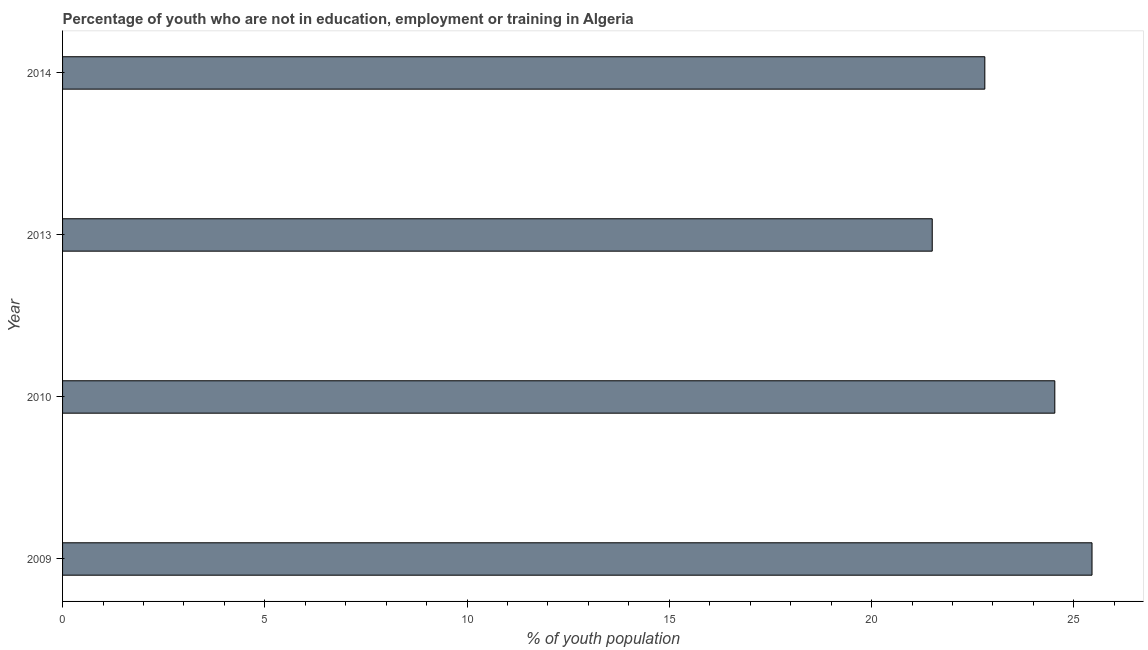Does the graph contain grids?
Make the answer very short. No. What is the title of the graph?
Make the answer very short. Percentage of youth who are not in education, employment or training in Algeria. What is the label or title of the X-axis?
Offer a very short reply. % of youth population. What is the label or title of the Y-axis?
Your answer should be compact. Year. What is the unemployed youth population in 2013?
Your answer should be very brief. 21.5. Across all years, what is the maximum unemployed youth population?
Ensure brevity in your answer.  25.45. Across all years, what is the minimum unemployed youth population?
Ensure brevity in your answer.  21.5. What is the sum of the unemployed youth population?
Give a very brief answer. 94.28. What is the difference between the unemployed youth population in 2009 and 2010?
Your response must be concise. 0.92. What is the average unemployed youth population per year?
Give a very brief answer. 23.57. What is the median unemployed youth population?
Offer a very short reply. 23.66. What is the ratio of the unemployed youth population in 2009 to that in 2010?
Your response must be concise. 1.04. Is the unemployed youth population in 2009 less than that in 2010?
Your answer should be compact. No. Is the difference between the unemployed youth population in 2010 and 2013 greater than the difference between any two years?
Keep it short and to the point. No. What is the difference between the highest and the lowest unemployed youth population?
Make the answer very short. 3.95. In how many years, is the unemployed youth population greater than the average unemployed youth population taken over all years?
Provide a succinct answer. 2. How many bars are there?
Your answer should be very brief. 4. How many years are there in the graph?
Offer a terse response. 4. What is the difference between two consecutive major ticks on the X-axis?
Offer a terse response. 5. What is the % of youth population in 2009?
Offer a terse response. 25.45. What is the % of youth population of 2010?
Make the answer very short. 24.53. What is the % of youth population in 2014?
Your response must be concise. 22.8. What is the difference between the % of youth population in 2009 and 2010?
Offer a terse response. 0.92. What is the difference between the % of youth population in 2009 and 2013?
Provide a short and direct response. 3.95. What is the difference between the % of youth population in 2009 and 2014?
Provide a short and direct response. 2.65. What is the difference between the % of youth population in 2010 and 2013?
Offer a very short reply. 3.03. What is the difference between the % of youth population in 2010 and 2014?
Ensure brevity in your answer.  1.73. What is the difference between the % of youth population in 2013 and 2014?
Ensure brevity in your answer.  -1.3. What is the ratio of the % of youth population in 2009 to that in 2010?
Give a very brief answer. 1.04. What is the ratio of the % of youth population in 2009 to that in 2013?
Offer a very short reply. 1.18. What is the ratio of the % of youth population in 2009 to that in 2014?
Keep it short and to the point. 1.12. What is the ratio of the % of youth population in 2010 to that in 2013?
Your answer should be compact. 1.14. What is the ratio of the % of youth population in 2010 to that in 2014?
Provide a short and direct response. 1.08. What is the ratio of the % of youth population in 2013 to that in 2014?
Keep it short and to the point. 0.94. 